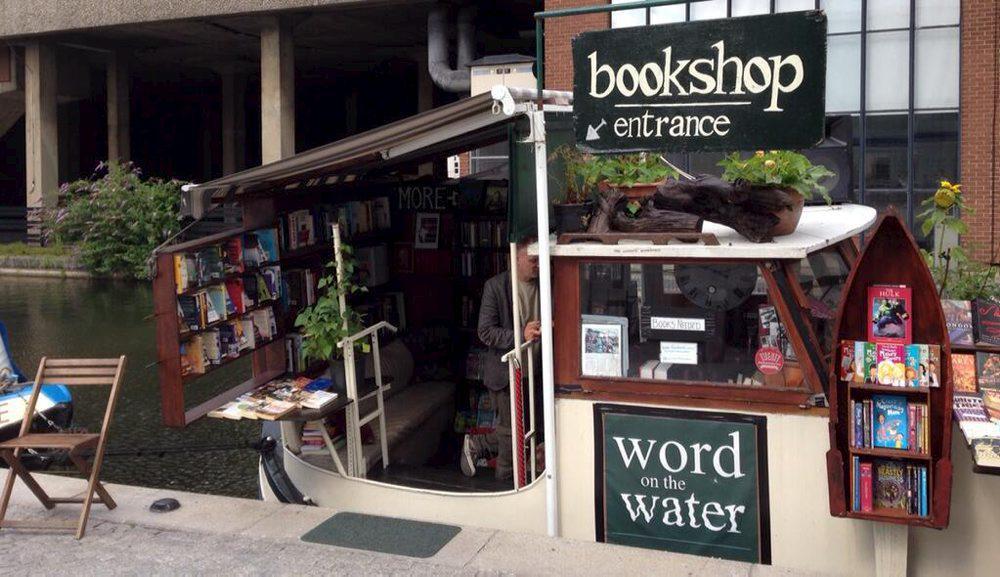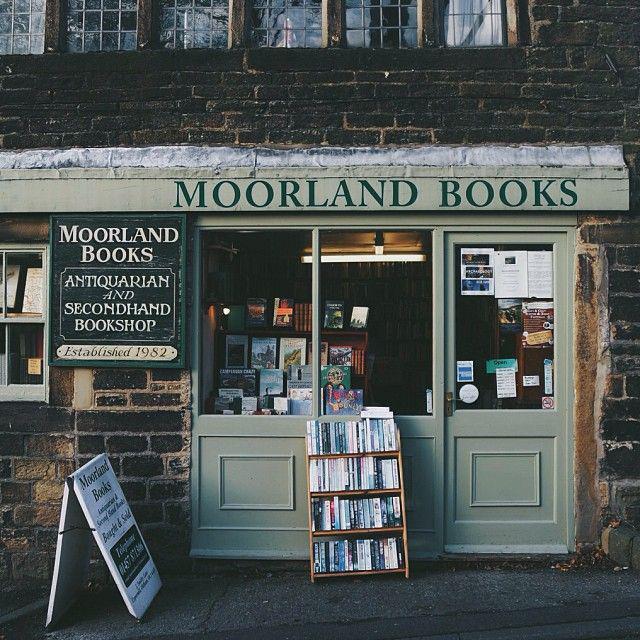The first image is the image on the left, the second image is the image on the right. Assess this claim about the two images: "Both images include book shop exteriors.". Correct or not? Answer yes or no. Yes. The first image is the image on the left, the second image is the image on the right. Given the left and right images, does the statement "In one image, at least one person is inside a book store that has books shelved to the ceiling." hold true? Answer yes or no. No. 